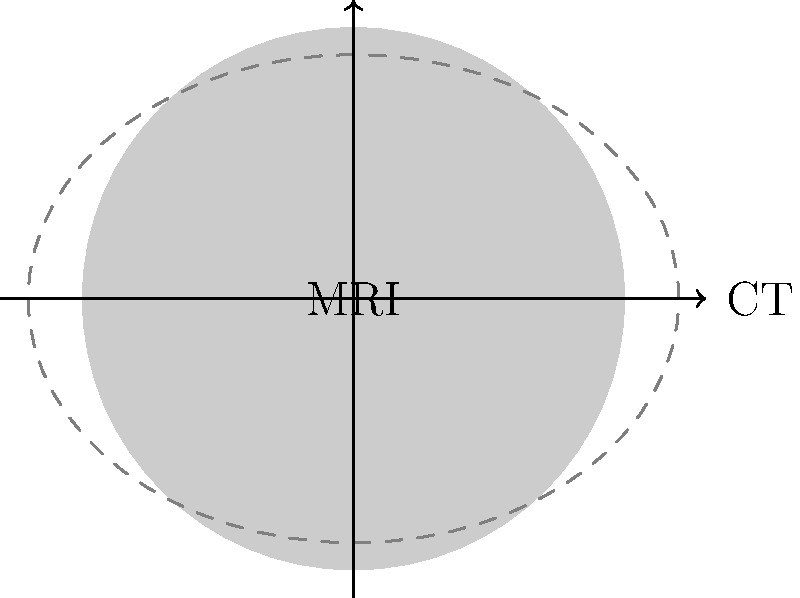In the image above, two different modalities (MRI and CT) of the same anatomical region are shown. The CT image (dashed outline) is misaligned with the MRI image (solid gray circle). What image registration technique would be most appropriate to align these images, and what transformation should be applied? To answer this question, let's analyze the misalignment and consider the appropriate image registration technique:

1. Observe the misalignment:
   - The CT image (dashed outline) is slightly larger and rotated compared to the MRI image (solid gray circle).
   - There's a shift in both horizontal and vertical directions.

2. Identify the types of transformations needed:
   - Scaling: The CT image needs to be scaled down to match the MRI image size.
   - Rotation: A slight rotation is required to align the CT image with the MRI image.
   - Translation: The CT image needs to be shifted in both x and y directions.

3. Determine the appropriate registration technique:
   - Since we need scaling, rotation, and translation, we require a rigid + scaling transformation.
   - This type of transformation is known as a similarity transformation.

4. Choose the registration method:
   - For multimodal images (MRI and CT), intensity-based registration methods are often preferred.
   - Mutual Information (MI) or Normalized Mutual Information (NMI) are commonly used similarity metrics for multimodal registration.

5. Propose the registration approach:
   - Use an intensity-based registration method with MI or NMI as the similarity metric.
   - Apply a similarity transformation (rigid + scaling) to align the CT image with the MRI image.

Therefore, the most appropriate technique would be an intensity-based registration using Mutual Information (or Normalized Mutual Information) as the similarity metric, applying a similarity transformation to align the CT image with the MRI image.
Answer: Intensity-based registration with MI/NMI, applying similarity transformation 